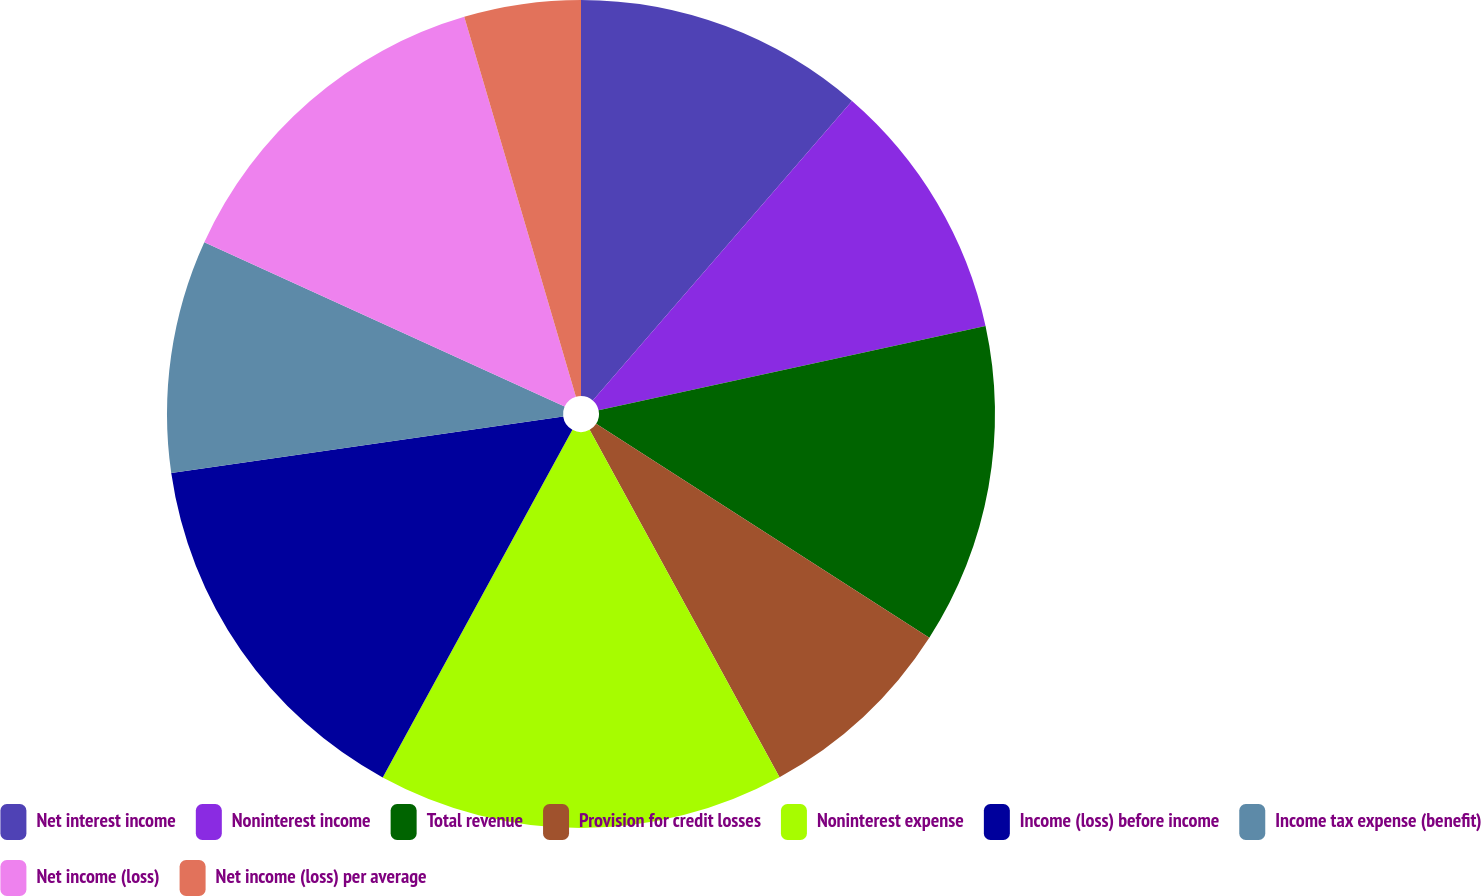Convert chart to OTSL. <chart><loc_0><loc_0><loc_500><loc_500><pie_chart><fcel>Net interest income<fcel>Noninterest income<fcel>Total revenue<fcel>Provision for credit losses<fcel>Noninterest expense<fcel>Income (loss) before income<fcel>Income tax expense (benefit)<fcel>Net income (loss)<fcel>Net income (loss) per average<nl><fcel>11.36%<fcel>10.23%<fcel>12.5%<fcel>7.95%<fcel>15.91%<fcel>14.77%<fcel>9.09%<fcel>13.64%<fcel>4.55%<nl></chart> 